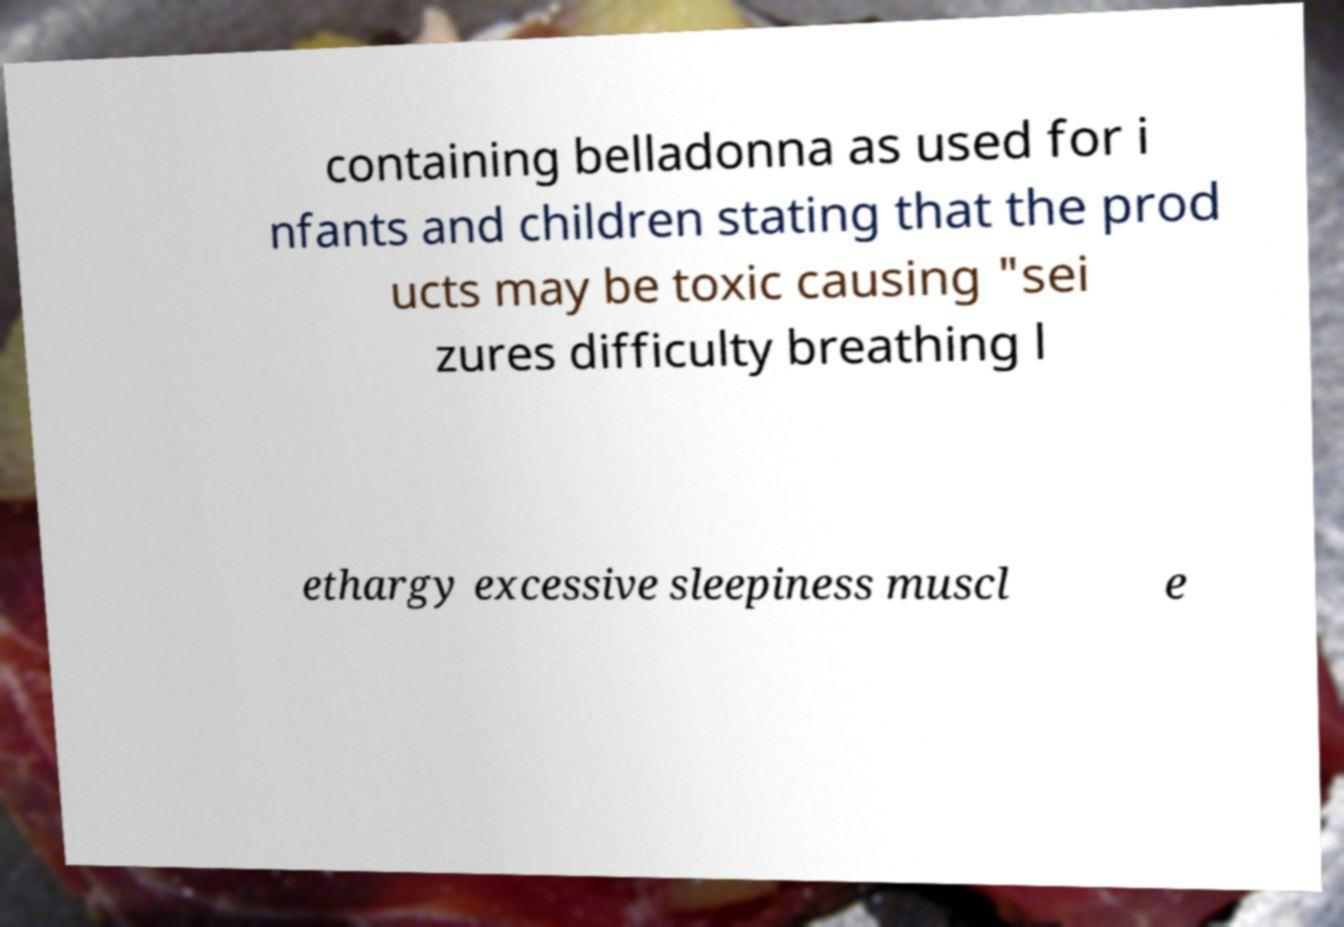Could you assist in decoding the text presented in this image and type it out clearly? containing belladonna as used for i nfants and children stating that the prod ucts may be toxic causing "sei zures difficulty breathing l ethargy excessive sleepiness muscl e 